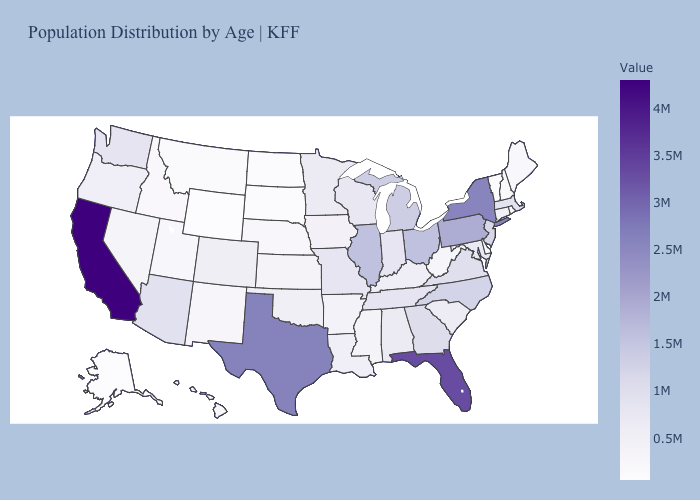Does North Carolina have a lower value than California?
Be succinct. Yes. Does the map have missing data?
Keep it brief. No. Which states have the lowest value in the South?
Answer briefly. Delaware. Among the states that border Massachusetts , does New York have the highest value?
Quick response, please. Yes. Does New Hampshire have the lowest value in the USA?
Answer briefly. No. Among the states that border Maine , which have the highest value?
Be succinct. New Hampshire. Which states have the highest value in the USA?
Concise answer only. California. Is the legend a continuous bar?
Concise answer only. Yes. Which states have the highest value in the USA?
Be succinct. California. Among the states that border Rhode Island , does Massachusetts have the highest value?
Keep it brief. Yes. 